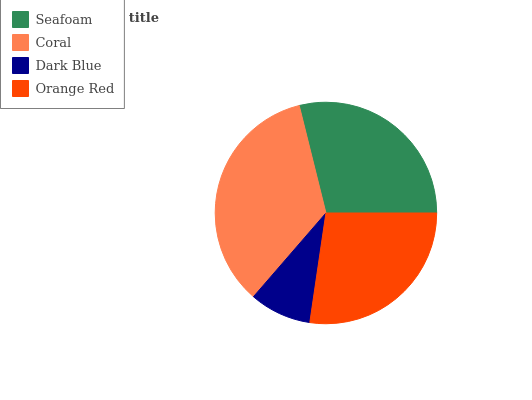Is Dark Blue the minimum?
Answer yes or no. Yes. Is Coral the maximum?
Answer yes or no. Yes. Is Coral the minimum?
Answer yes or no. No. Is Dark Blue the maximum?
Answer yes or no. No. Is Coral greater than Dark Blue?
Answer yes or no. Yes. Is Dark Blue less than Coral?
Answer yes or no. Yes. Is Dark Blue greater than Coral?
Answer yes or no. No. Is Coral less than Dark Blue?
Answer yes or no. No. Is Seafoam the high median?
Answer yes or no. Yes. Is Orange Red the low median?
Answer yes or no. Yes. Is Orange Red the high median?
Answer yes or no. No. Is Coral the low median?
Answer yes or no. No. 